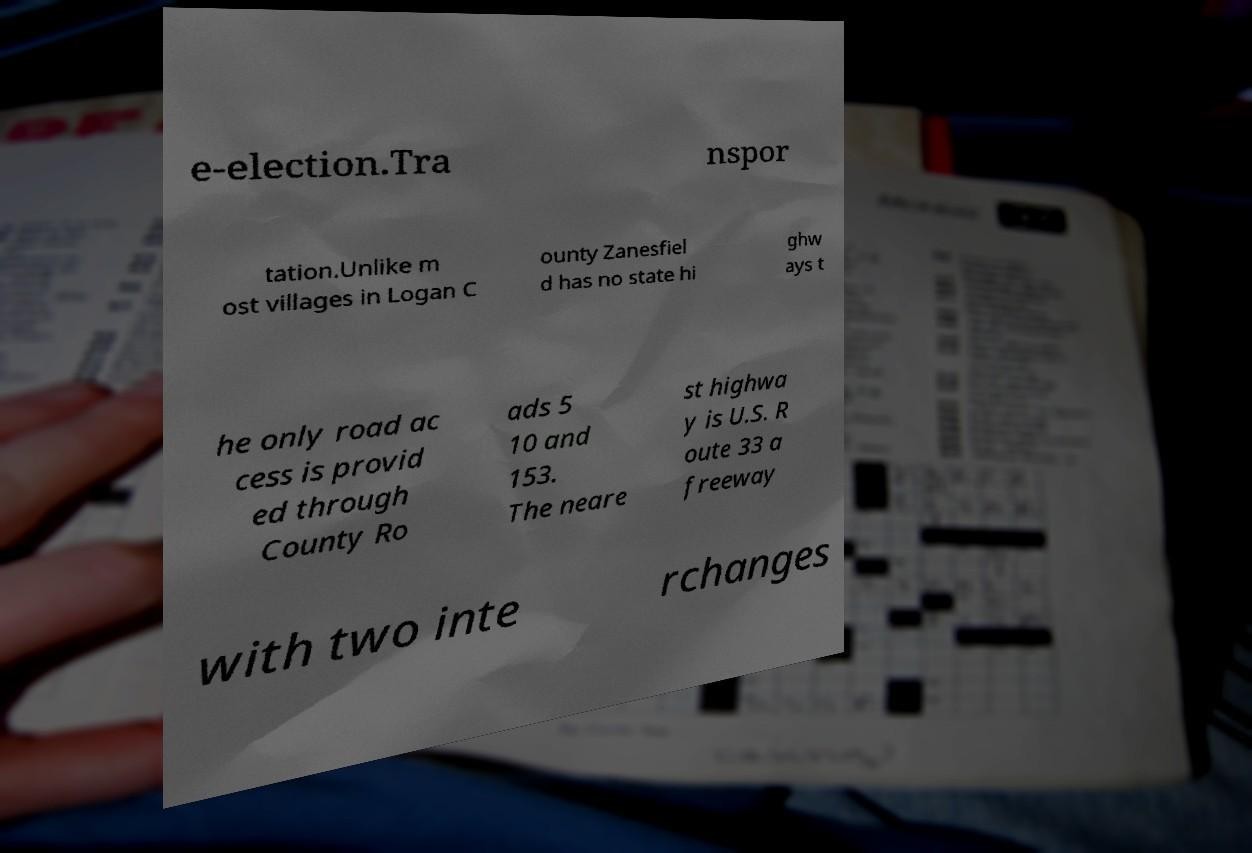What messages or text are displayed in this image? I need them in a readable, typed format. e-election.Tra nspor tation.Unlike m ost villages in Logan C ounty Zanesfiel d has no state hi ghw ays t he only road ac cess is provid ed through County Ro ads 5 10 and 153. The neare st highwa y is U.S. R oute 33 a freeway with two inte rchanges 